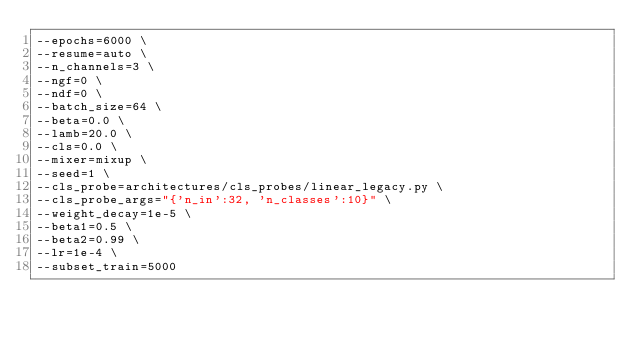Convert code to text. <code><loc_0><loc_0><loc_500><loc_500><_Bash_>--epochs=6000 \
--resume=auto \
--n_channels=3 \
--ngf=0 \
--ndf=0 \
--batch_size=64 \
--beta=0.0 \
--lamb=20.0 \
--cls=0.0 \
--mixer=mixup \
--seed=1 \
--cls_probe=architectures/cls_probes/linear_legacy.py \
--cls_probe_args="{'n_in':32, 'n_classes':10}" \
--weight_decay=1e-5 \
--beta1=0.5 \
--beta2=0.99 \
--lr=1e-4 \
--subset_train=5000
</code> 